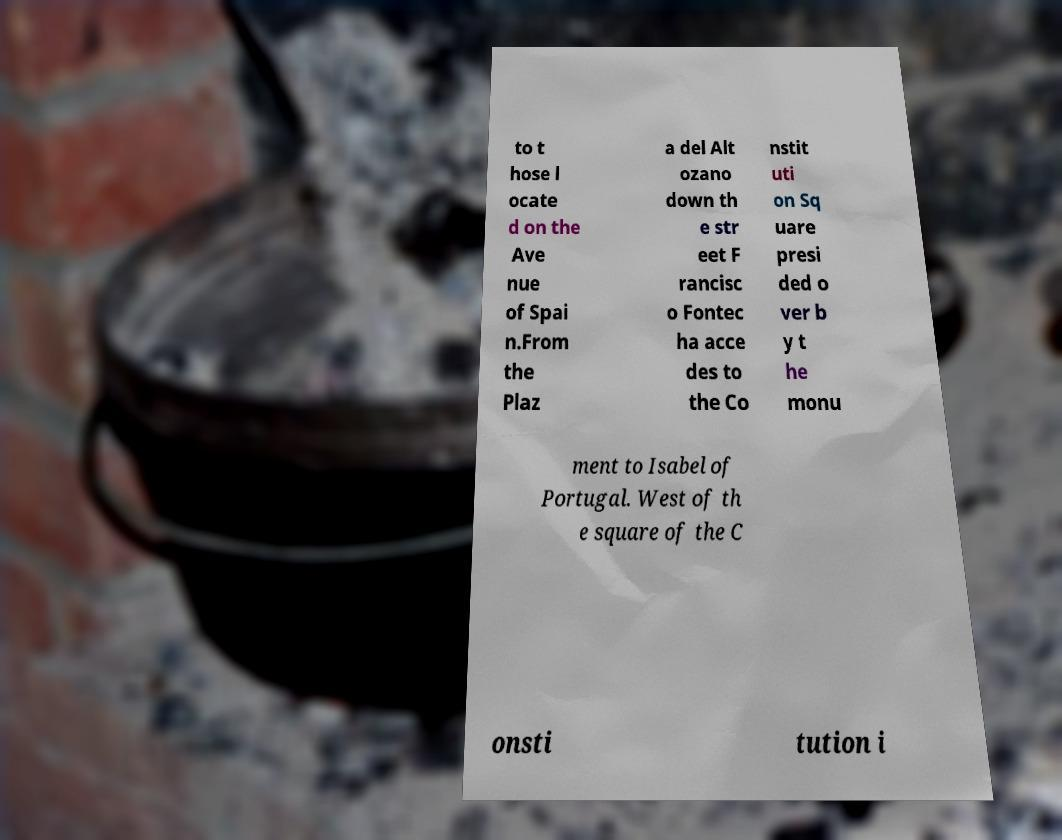Could you extract and type out the text from this image? to t hose l ocate d on the Ave nue of Spai n.From the Plaz a del Alt ozano down th e str eet F rancisc o Fontec ha acce des to the Co nstit uti on Sq uare presi ded o ver b y t he monu ment to Isabel of Portugal. West of th e square of the C onsti tution i 